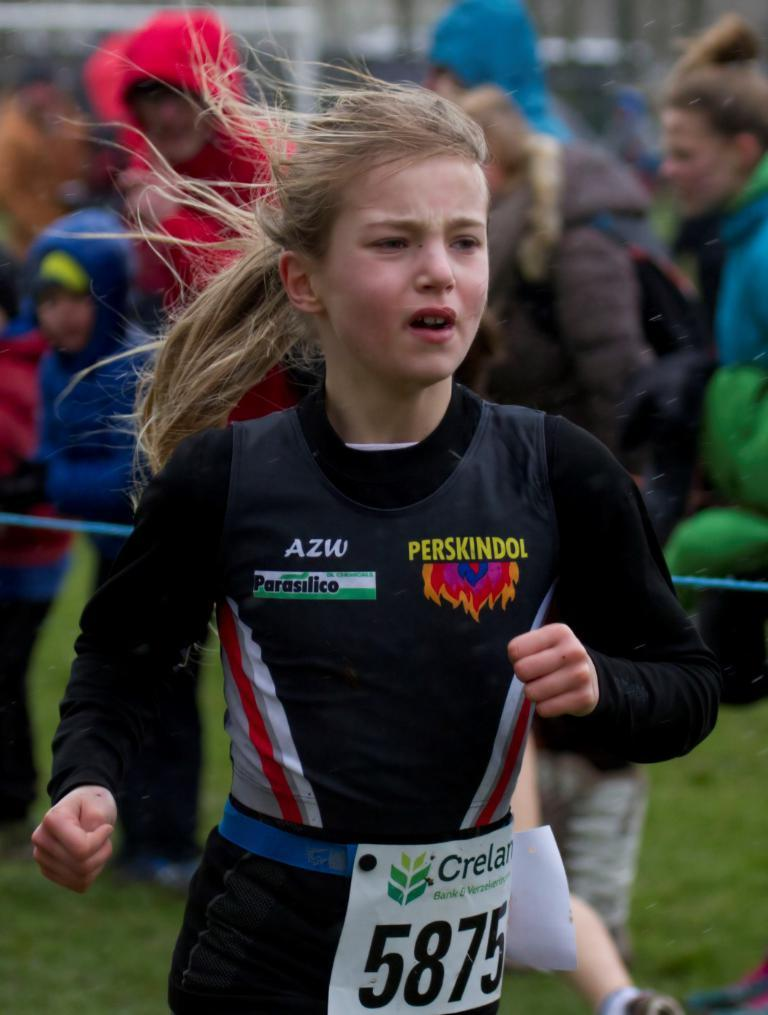What is the girl in the image doing? The girl is running in the image. What can be seen in the background of the image? There are people standing in the background of the image. What type of surface is the girl running on? The ground appears to be grass. What type of wheel is visible in the image? There is no wheel present in the image. Is the girl running in the rain in the image? The image does not show any rain, so it cannot be determined if the girl is running in the rain. 